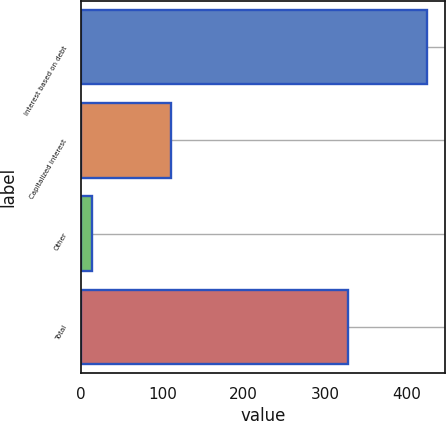<chart> <loc_0><loc_0><loc_500><loc_500><bar_chart><fcel>Interest based on debt<fcel>Capitalized interest<fcel>Other<fcel>Total<nl><fcel>426<fcel>111<fcel>14<fcel>329<nl></chart> 